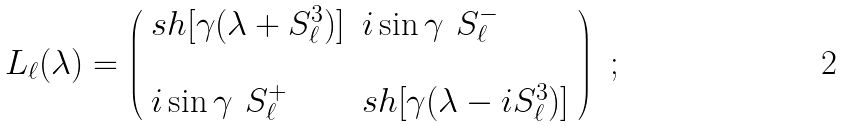Convert formula to latex. <formula><loc_0><loc_0><loc_500><loc_500>L _ { \ell } ( \lambda ) = \left ( \begin{array} { l l } s h [ \gamma ( \lambda + S ^ { 3 } _ { \ell } ) ] & i \sin \gamma \ S ^ { - } _ { \ell } \\ & \\ i \sin \gamma \ S ^ { + } _ { \ell } & s h [ \gamma ( \lambda - i S ^ { 3 } _ { \ell } ) ] \end{array} \right ) \ ;</formula> 